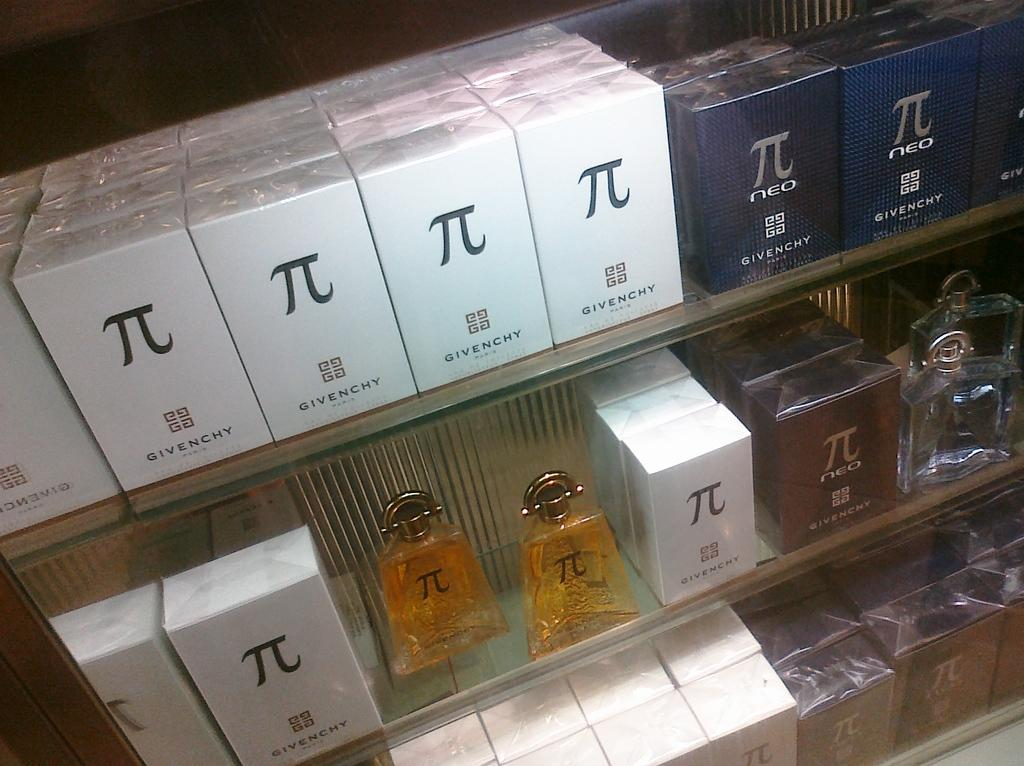<image>
Summarize the visual content of the image. A lot of Givenchy cologne boxes on shelves. 